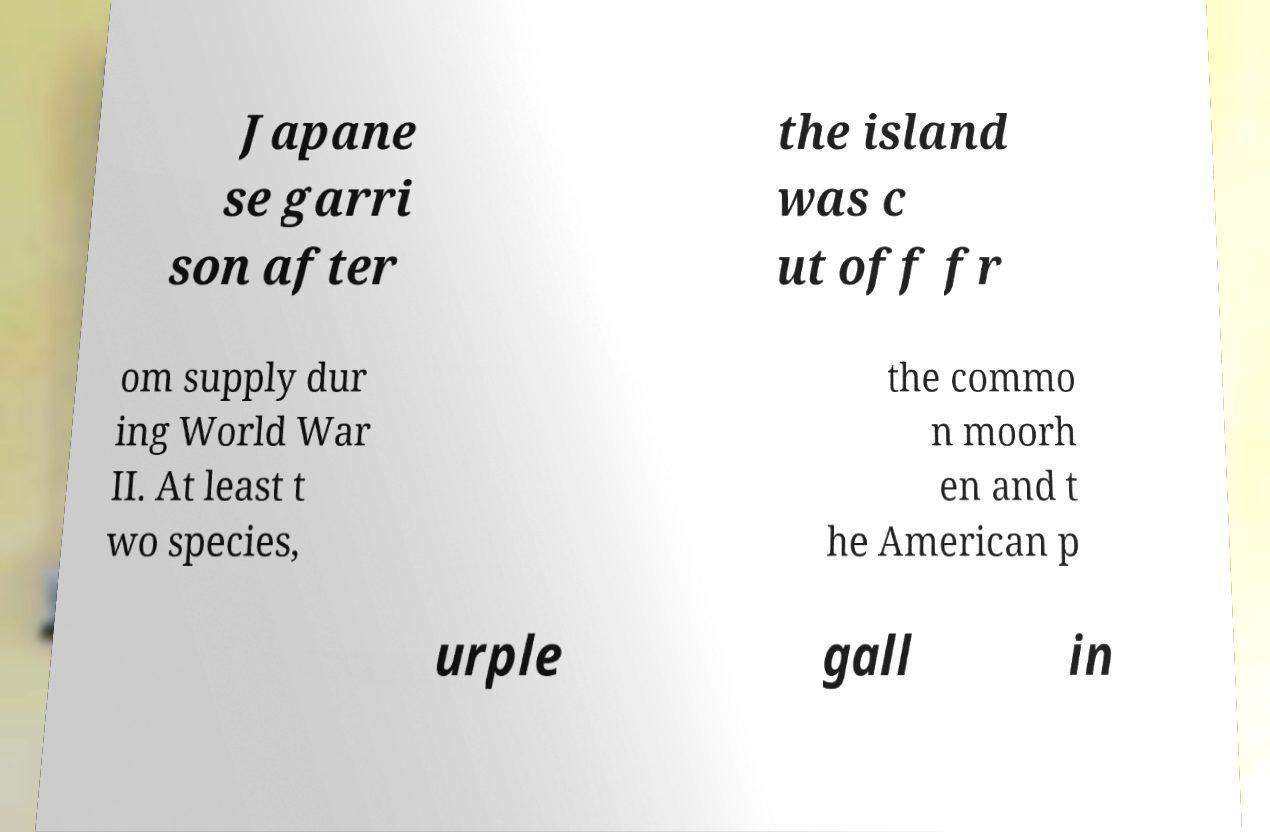Could you assist in decoding the text presented in this image and type it out clearly? Japane se garri son after the island was c ut off fr om supply dur ing World War II. At least t wo species, the commo n moorh en and t he American p urple gall in 